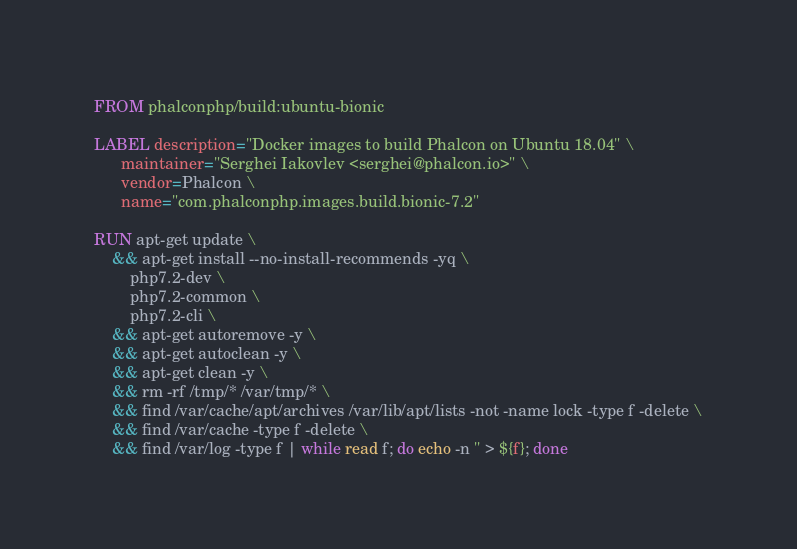Convert code to text. <code><loc_0><loc_0><loc_500><loc_500><_Dockerfile_>FROM phalconphp/build:ubuntu-bionic

LABEL description="Docker images to build Phalcon on Ubuntu 18.04" \
      maintainer="Serghei Iakovlev <serghei@phalcon.io>" \
      vendor=Phalcon \
      name="com.phalconphp.images.build.bionic-7.2"

RUN apt-get update \
    && apt-get install --no-install-recommends -yq \
        php7.2-dev \
        php7.2-common \
        php7.2-cli \
    && apt-get autoremove -y \
    && apt-get autoclean -y \
    && apt-get clean -y \
    && rm -rf /tmp/* /var/tmp/* \
    && find /var/cache/apt/archives /var/lib/apt/lists -not -name lock -type f -delete \
    && find /var/cache -type f -delete \
    && find /var/log -type f | while read f; do echo -n '' > ${f}; done
</code> 